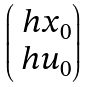<formula> <loc_0><loc_0><loc_500><loc_500>\begin{pmatrix} \ h x _ { 0 } \\ \ h u _ { 0 } \end{pmatrix}</formula> 